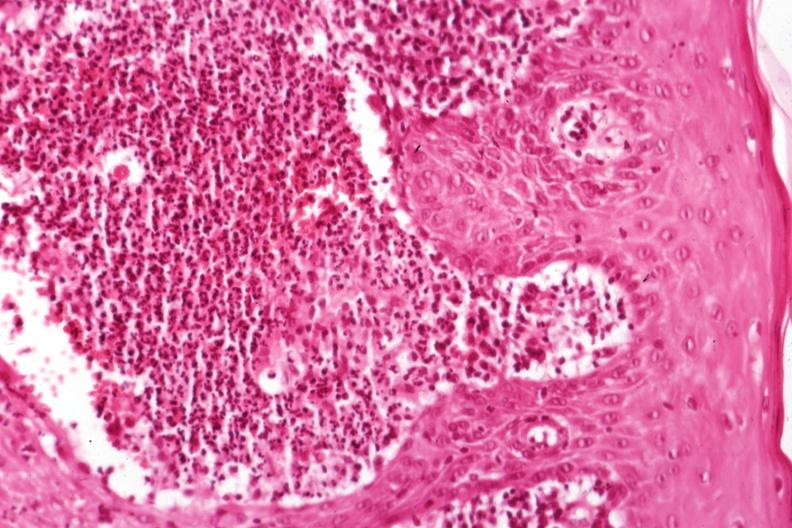where is this?
Answer the question using a single word or phrase. Skin 